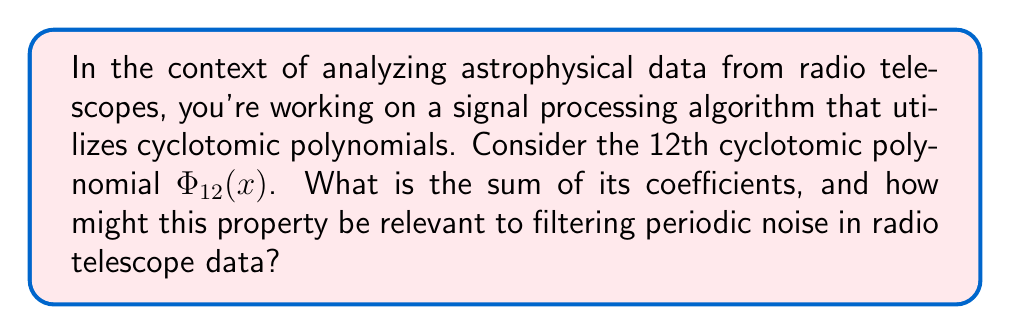Teach me how to tackle this problem. Let's approach this step-by-step:

1) First, we need to determine $\Phi_{12}(x)$. The 12th cyclotomic polynomial is:

   $$\Phi_{12}(x) = x^4 - x^2 + 1$$

2) To find the sum of its coefficients, we simply add them:

   $1 + (-1) + 0 + 1 = 1$

3) This sum being 1 is not a coincidence. In fact, for any cyclotomic polynomial $\Phi_n(x)$, the sum of its coefficients is always equal to $\mu(n)$, where $\mu(n)$ is the Möbius function.

4) For $n = 12$, $\mu(12) = 1$ because 12 is a product of an even number of distinct primes (2 and 3).

5) This property is relevant to signal processing in astrophysics for several reasons:

   a) Cyclotomic polynomials have roots that are primitive nth roots of unity, making them useful for analyzing periodic signals.
   
   b) The fact that the sum of coefficients is 1 (for this case) means that when applied as a filter, it preserves the DC component of the signal while attenuating specific periodic components.
   
   c) In radio telescope data, periodic noise often comes from human-made sources or natural periodic phenomena. Filters based on cyclotomic polynomials can be designed to remove these specific frequencies while minimally affecting the rest of the signal.

6) For computational fluid dynamics in astrophysics, this property could be used in spectral methods for solving partial differential equations, where cyclotomic polynomials can help in efficiently computing discrete Fourier transforms.
Answer: 1 